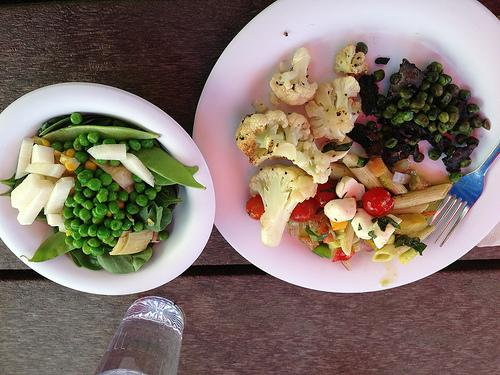Write a description of the picture as if it's a scene from a novel. The aroma of freshly steamed cauliflower and vibrant green peas filled the modest kitchen, as the late afternoon sun cast a warm glow over the meticulously arranged plates and bowl atop the aged, wooden table. A solitary glass of water glistened in the sunlight, while a fork lay in anticipation of the coming meal. Provide a brief and informal description of the main elements in the image. There's a plate and bowl full of veggies, a glass of water, a fork, and some peas and cauliflower on a wooden table, all ready to be eaten! Create a list of the major items seen in the picture. White plate, white bowl, glass of water, steamed cauliflower, green peas in bowl, cherry tomato, fork on plate, wooden table, mozzarella cheese. Pretend you're a character in a video game who has just encountered this scene. Describe what you see. As I enter the quaint little kitchen, I spot a wooden table with a white plate and bowl filled with quest-worthy vegetables. A cherry tomato gleams like a tiny gem, and a glass of water shimmers with magical properties. Beside the plate lies a shiny fork, no doubt a valuable tool in my upcoming culinary adventure. Construct a formal description of the image focusing on its contents. Displayed on a brown wooden table, one can observe a white plate with various vegetables, a white bowl filled with vegetables, a clear drinking glass containing water, a cherry tomato, a fork resting upon a plate, and mozzarella cheese. In a poetic manner, describe the elements found in the image. Upon a rustic, wooden stage lies a bounty of nature's gifts, with plates adorning veggies green and white, a cherry tomato glistening bright, a fork to partake in this wholesome feast, and a glass of water to quench the thirst. Mention three main elements in the image and describe their position. A white plate laden with vegetables sits at the top left, a bowl of green peas in the middle, and a clear glass of water on the right side of the wooden table. Imagine this image is part of a healthy eating campaign, and describe it accordingly. Feast your eyes on this array of nutritious delights: a plate and a bowl filled with fiber-rich greens, steamed cauliflower and snap peas, alongside a cherry tomato packed with vitamins. With a glass of water to hydrate and a fork poised for action, it's the perfect example of a heart-healthy meal! Describe the image as if you were narrating it in a children's storybook. Once upon a time, on a cozy wooden table, a plate and a bowl filled with colorful vegetables awaited little hungry mouths. A shiny fork stood ready for action, and a glass of water twinkled with delight! Describe the main objects in the image using alliteration. Pleasant plates packed with palatable produce, bountiful bowls brimming with bite-sized bits, and a gorgeous glass gleaming gracefully, all share the stage on the welcoming wooden wonderland. 